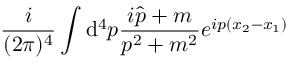<formula> <loc_0><loc_0><loc_500><loc_500>\frac { i } { ( 2 \pi ) ^ { 4 } } \int { \mathrm d } ^ { 4 } p \frac { i \hat { p } + m } { p ^ { 2 } + m ^ { 2 } } e ^ { i p ( x _ { 2 } - x _ { 1 } ) }</formula> 